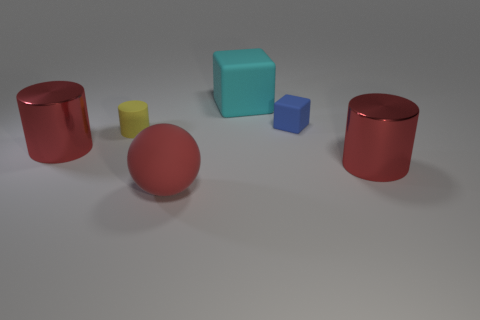Subtract all cyan cubes. Subtract all blue cylinders. How many cubes are left? 1 Add 1 yellow cylinders. How many objects exist? 7 Subtract all balls. How many objects are left? 5 Add 5 large red objects. How many large red objects exist? 8 Subtract 0 purple cubes. How many objects are left? 6 Subtract all yellow matte cylinders. Subtract all tiny red matte blocks. How many objects are left? 5 Add 1 large red rubber objects. How many large red rubber objects are left? 2 